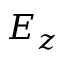<formula> <loc_0><loc_0><loc_500><loc_500>E _ { z }</formula> 